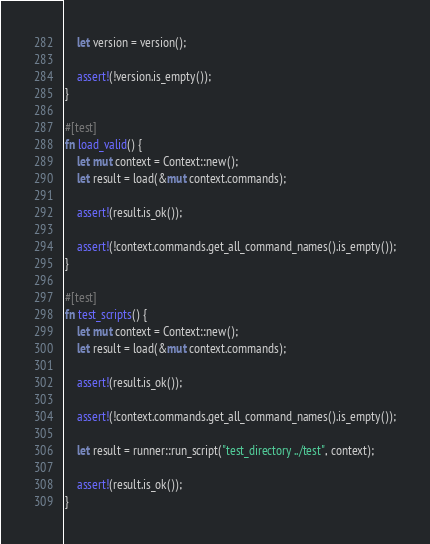Convert code to text. <code><loc_0><loc_0><loc_500><loc_500><_Rust_>    let version = version();

    assert!(!version.is_empty());
}

#[test]
fn load_valid() {
    let mut context = Context::new();
    let result = load(&mut context.commands);

    assert!(result.is_ok());

    assert!(!context.commands.get_all_command_names().is_empty());
}

#[test]
fn test_scripts() {
    let mut context = Context::new();
    let result = load(&mut context.commands);

    assert!(result.is_ok());

    assert!(!context.commands.get_all_command_names().is_empty());

    let result = runner::run_script("test_directory ../test", context);

    assert!(result.is_ok());
}
</code> 